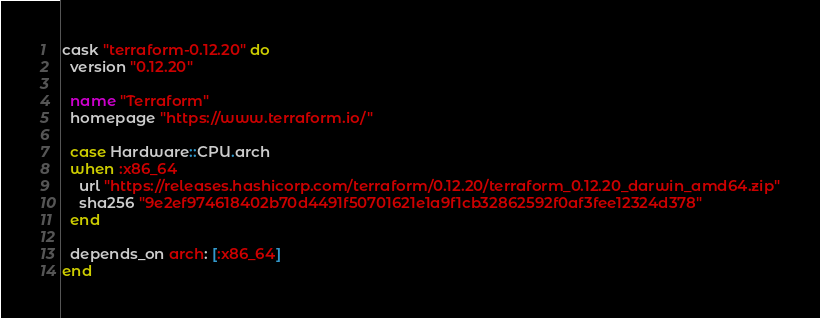Convert code to text. <code><loc_0><loc_0><loc_500><loc_500><_Ruby_>cask "terraform-0.12.20" do
  version "0.12.20"

  name "Terraform"
  homepage "https://www.terraform.io/"

  case Hardware::CPU.arch
  when :x86_64
    url "https://releases.hashicorp.com/terraform/0.12.20/terraform_0.12.20_darwin_amd64.zip"
    sha256 "9e2ef974618402b70d4491f50701621e1a9f1cb32862592f0af3fee12324d378"
  end

  depends_on arch: [:x86_64]
end
</code> 